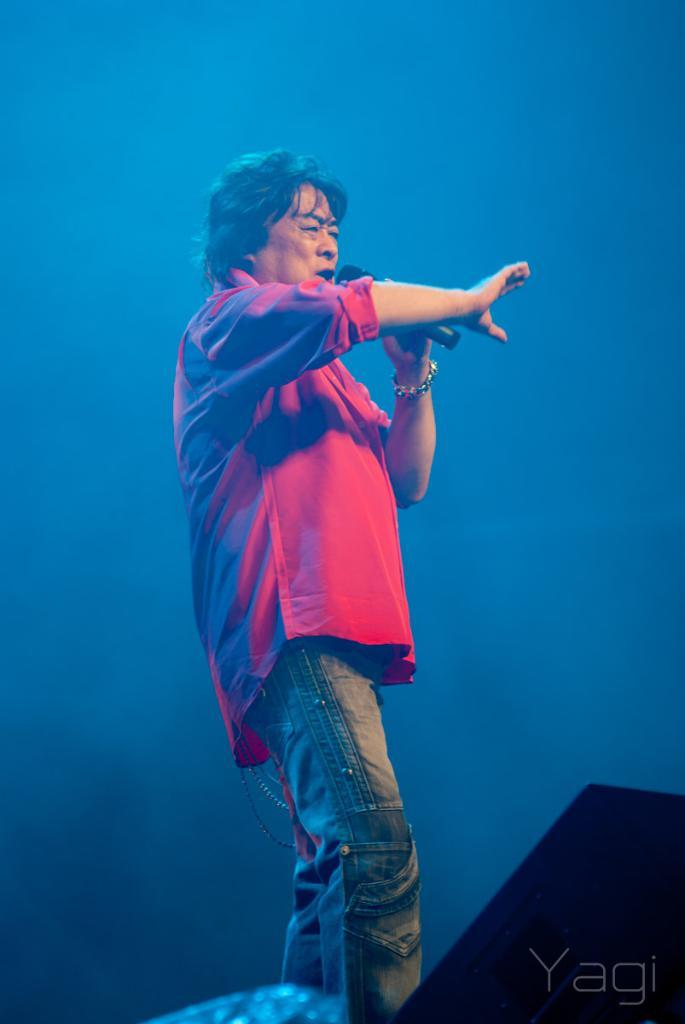Who is present in the image? There is a man in the image. What is the man wearing? The man is wearing a red color shirt. What is the man holding in the image? The man is holding a microphone (mike). What is the color of the background in the image? The background in the image is blue color. What type of rule does the governor enforce in the image? There is no governor present in the image, and therefore no rules to enforce. Can you describe the crow's behavior in the image? There are no crows present in the image. 